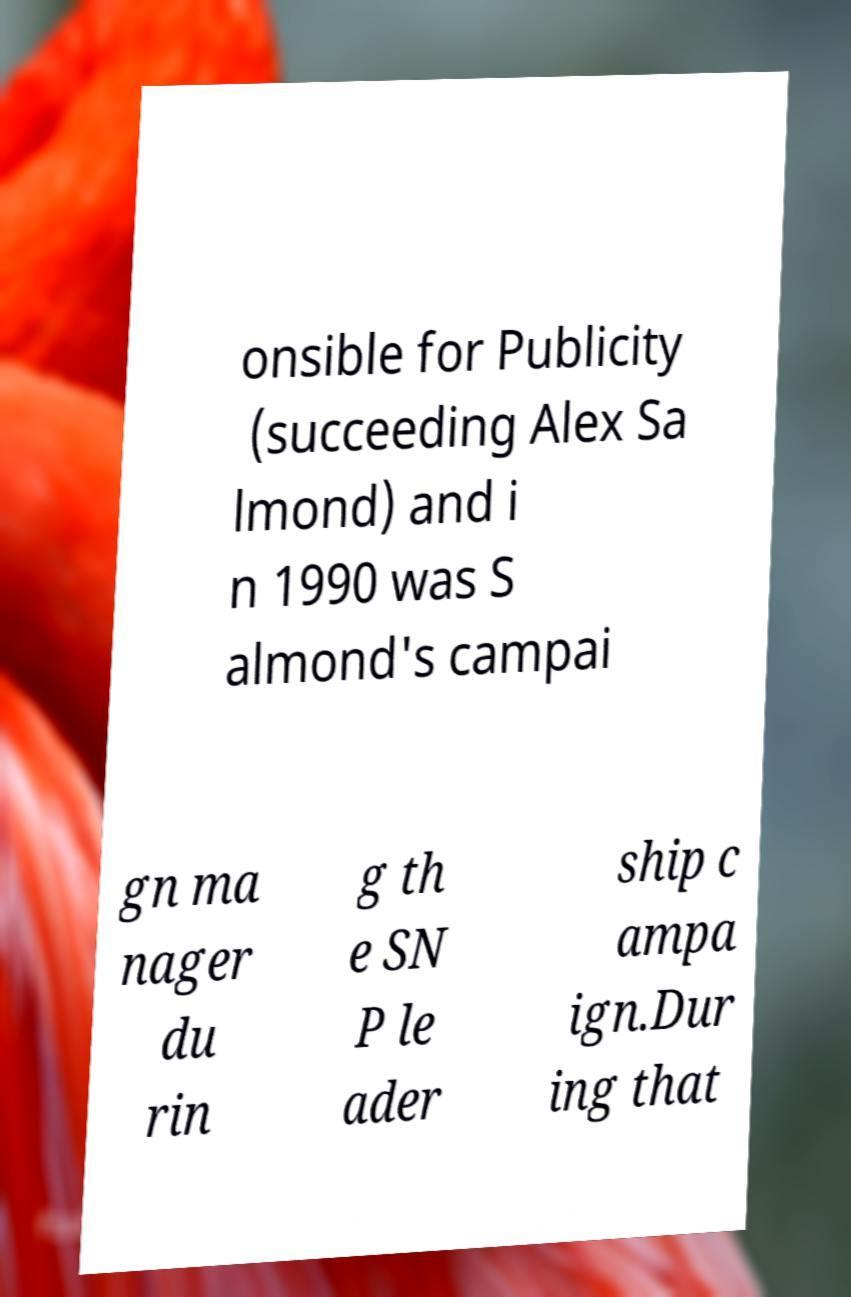Could you assist in decoding the text presented in this image and type it out clearly? onsible for Publicity (succeeding Alex Sa lmond) and i n 1990 was S almond's campai gn ma nager du rin g th e SN P le ader ship c ampa ign.Dur ing that 